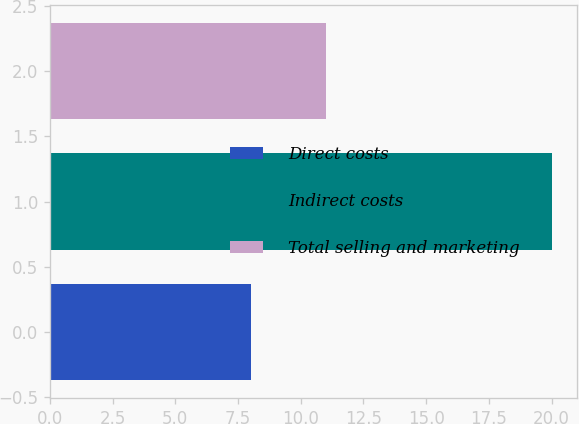<chart> <loc_0><loc_0><loc_500><loc_500><bar_chart><fcel>Direct costs<fcel>Indirect costs<fcel>Total selling and marketing<nl><fcel>8<fcel>20<fcel>11<nl></chart> 